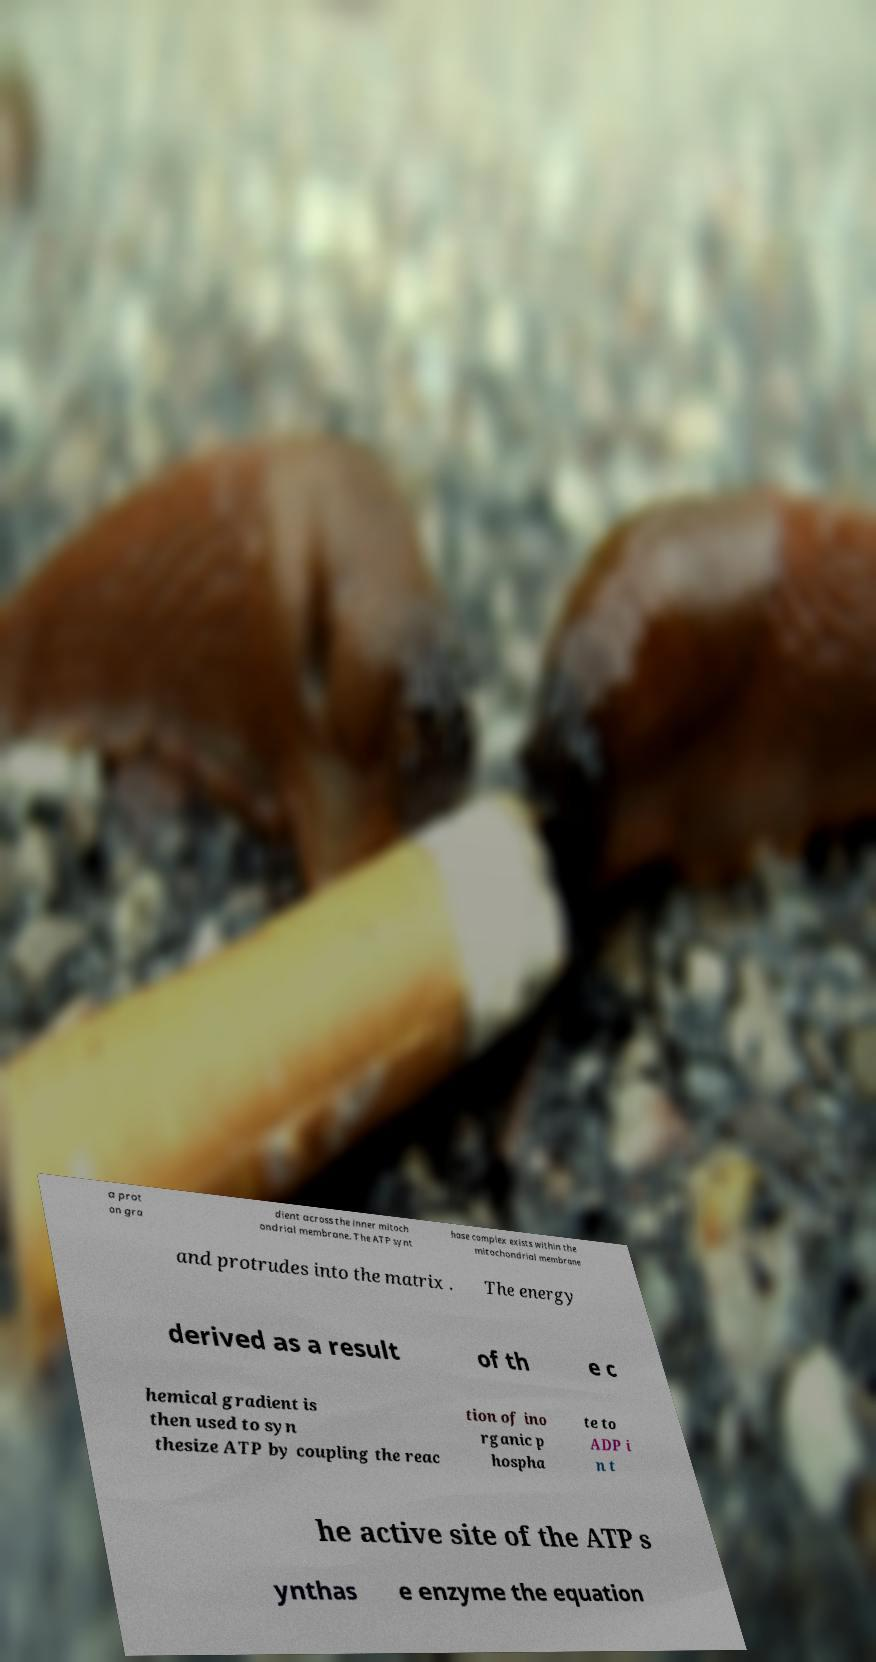Could you extract and type out the text from this image? a prot on gra dient across the inner mitoch ondrial membrane. The ATP synt hase complex exists within the mitochondrial membrane and protrudes into the matrix . The energy derived as a result of th e c hemical gradient is then used to syn thesize ATP by coupling the reac tion of ino rganic p hospha te to ADP i n t he active site of the ATP s ynthas e enzyme the equation 